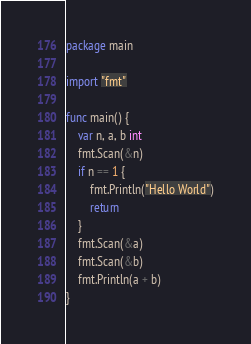<code> <loc_0><loc_0><loc_500><loc_500><_Go_>package main

import "fmt"

func main() {
	var n, a, b int
	fmt.Scan(&n)
	if n == 1 {
		fmt.Println("Hello World")
		return
	}
	fmt.Scan(&a)
	fmt.Scan(&b)
	fmt.Println(a + b)
}</code> 